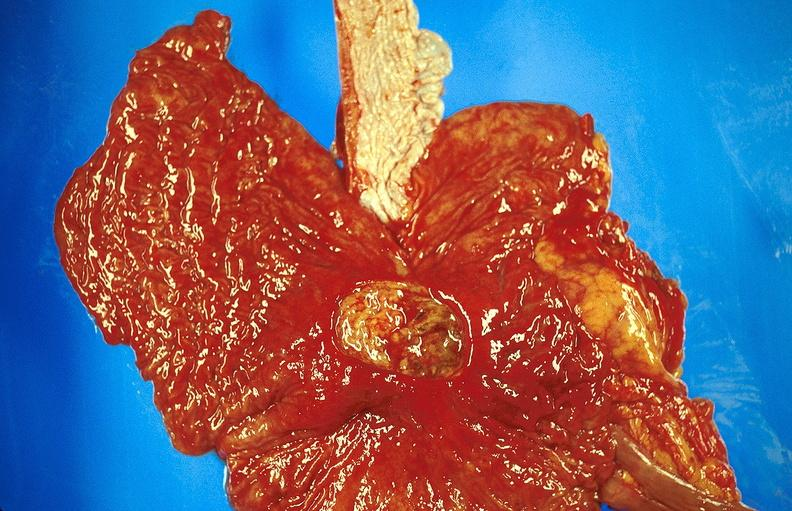what is present?
Answer the question using a single word or phrase. Gastrointestinal 